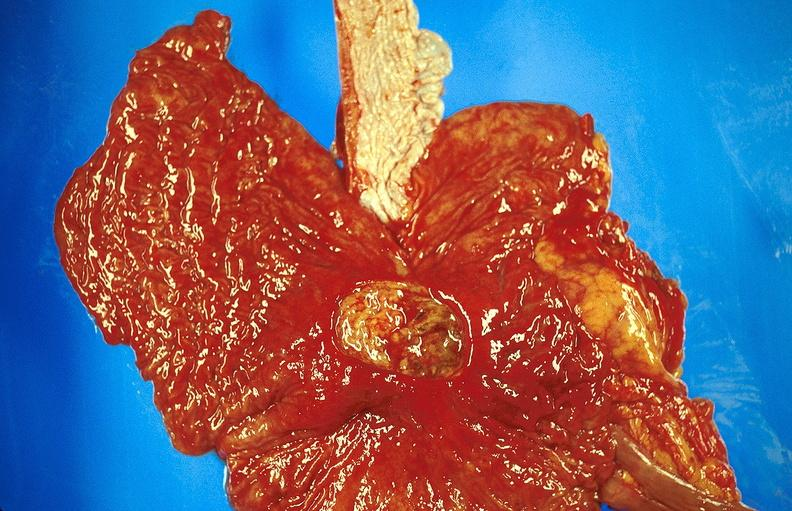what is present?
Answer the question using a single word or phrase. Gastrointestinal 